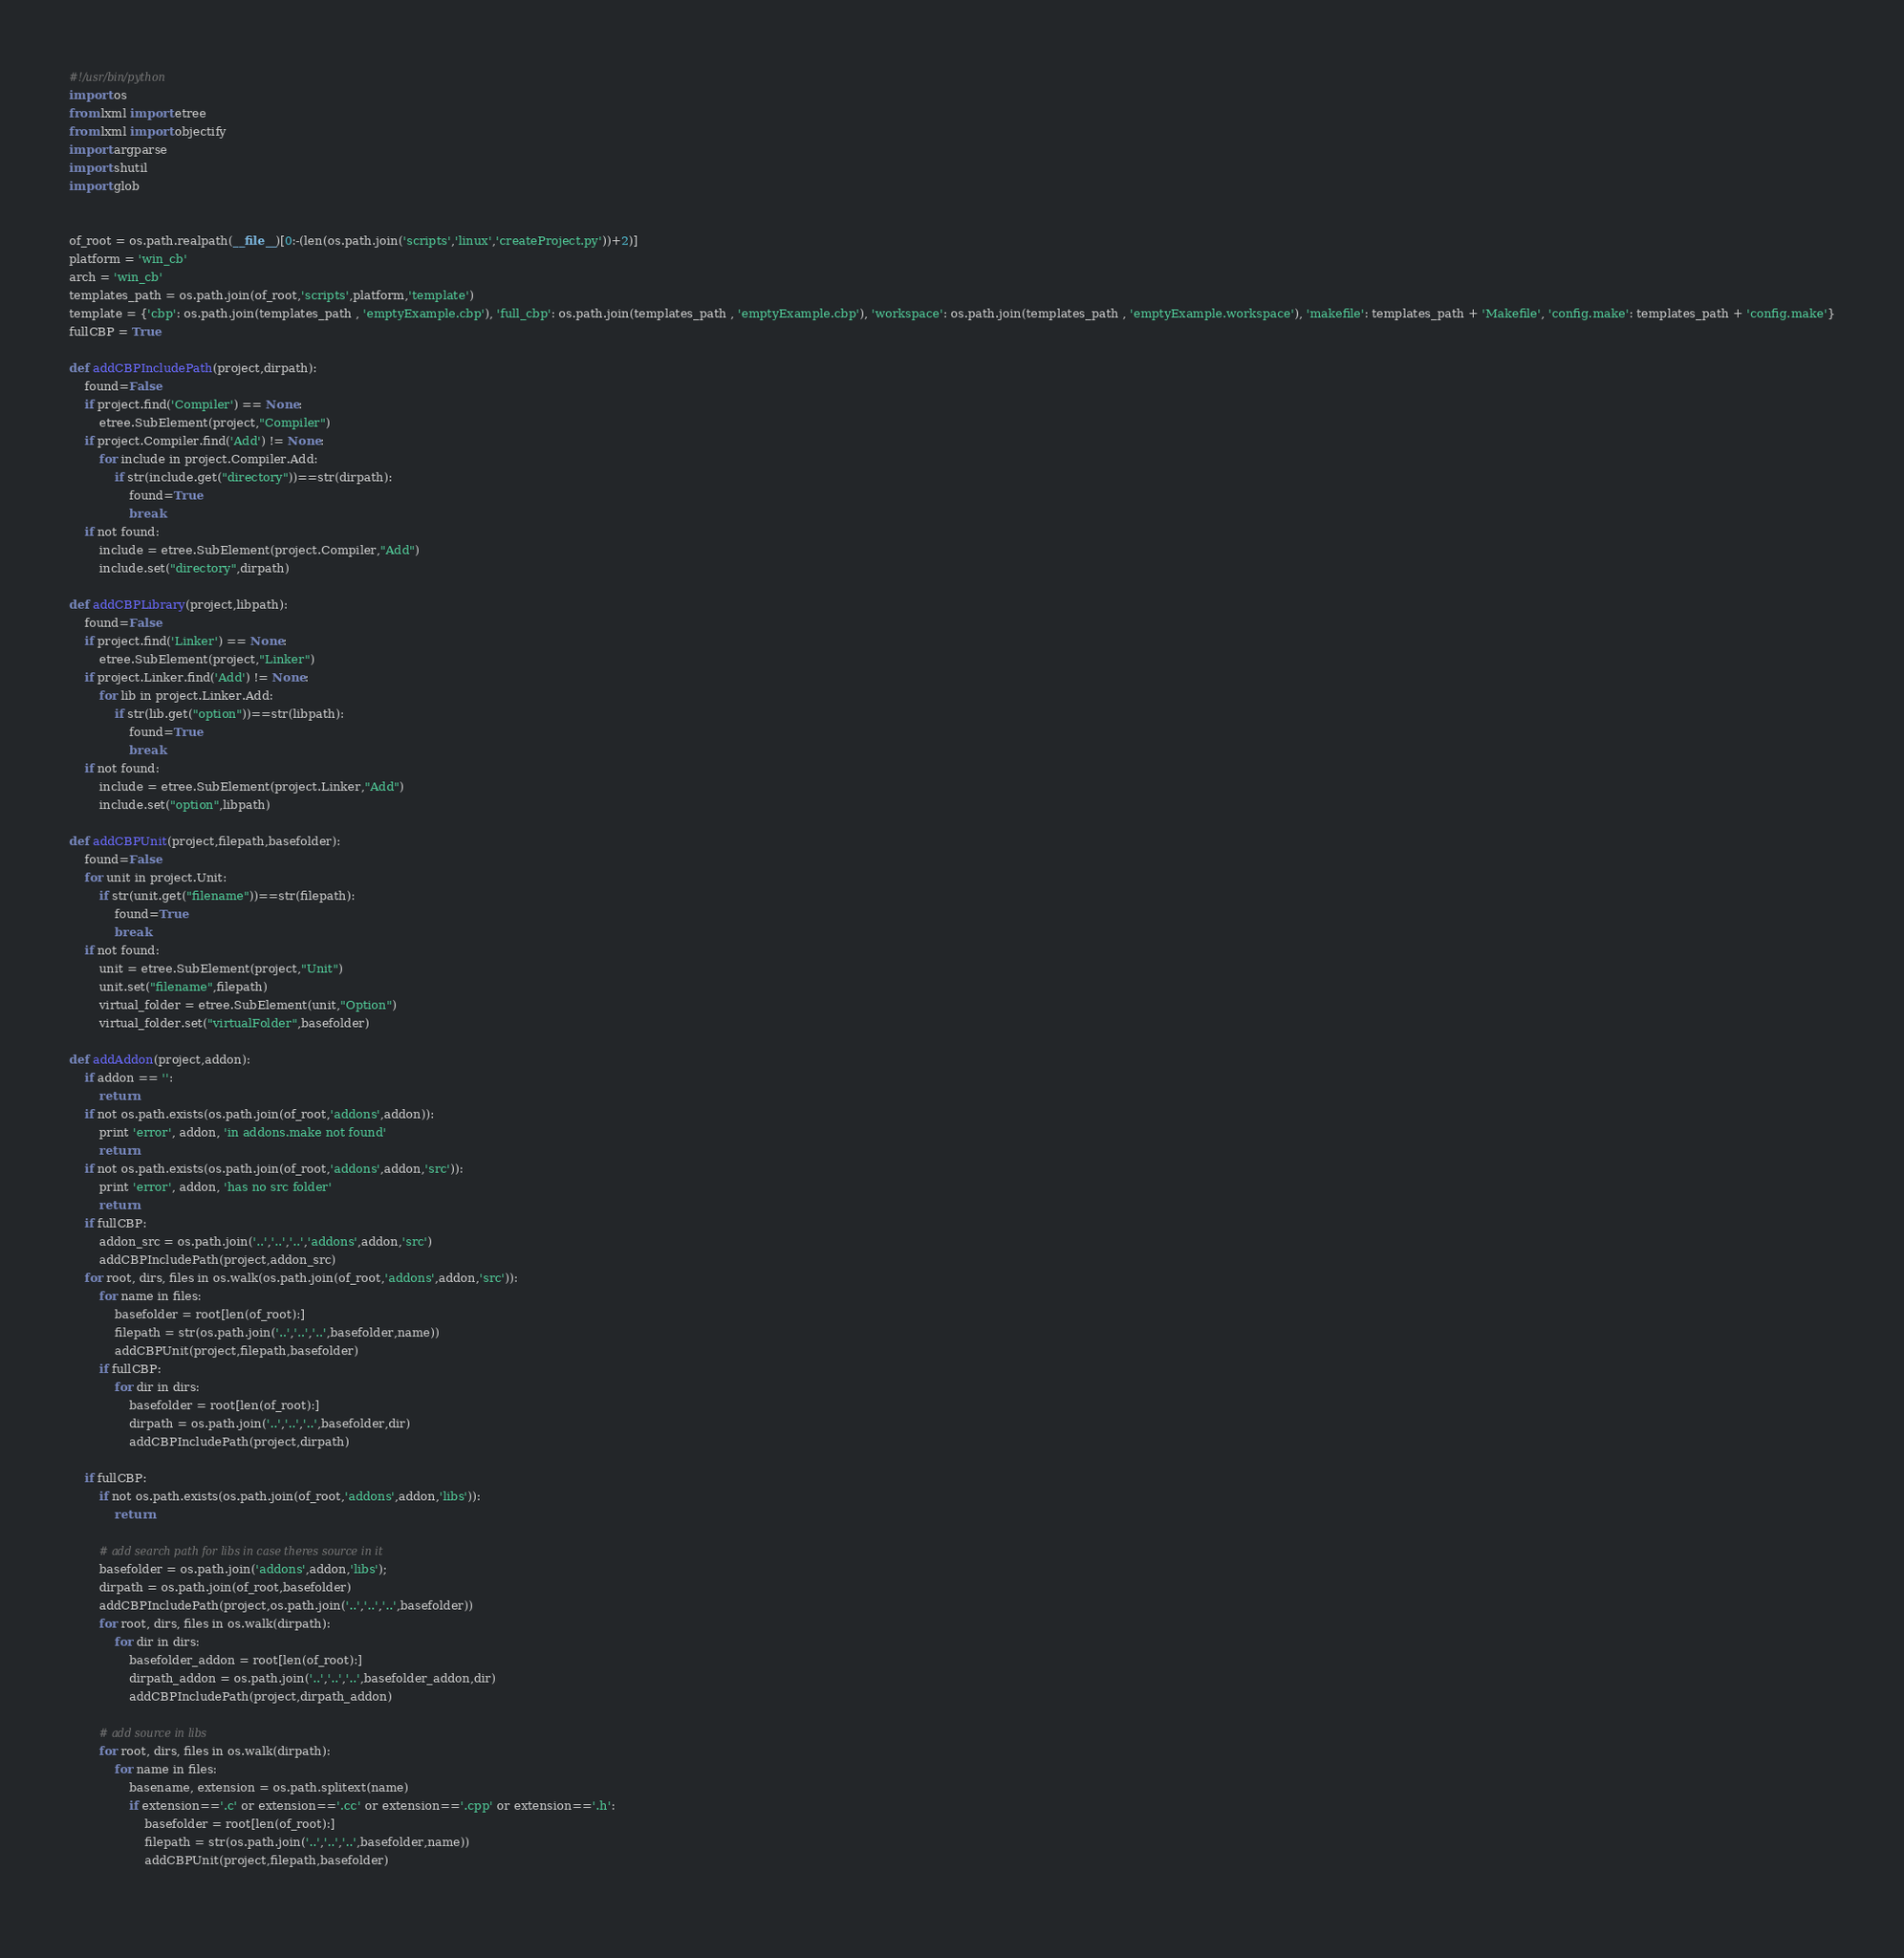Convert code to text. <code><loc_0><loc_0><loc_500><loc_500><_Python_>#!/usr/bin/python
import os
from lxml import etree
from lxml import objectify
import argparse
import shutil
import glob


of_root = os.path.realpath(__file__)[0:-(len(os.path.join('scripts','linux','createProject.py'))+2)]
platform = 'win_cb'
arch = 'win_cb'
templates_path = os.path.join(of_root,'scripts',platform,'template')
template = {'cbp': os.path.join(templates_path , 'emptyExample.cbp'), 'full_cbp': os.path.join(templates_path , 'emptyExample.cbp'), 'workspace': os.path.join(templates_path , 'emptyExample.workspace'), 'makefile': templates_path + 'Makefile', 'config.make': templates_path + 'config.make'}
fullCBP = True

def addCBPIncludePath(project,dirpath):
    found=False
    if project.find('Compiler') == None:
        etree.SubElement(project,"Compiler")
    if project.Compiler.find('Add') != None:
        for include in project.Compiler.Add:
            if str(include.get("directory"))==str(dirpath):
                found=True
                break
    if not found:
        include = etree.SubElement(project.Compiler,"Add")
        include.set("directory",dirpath)
        
def addCBPLibrary(project,libpath):
    found=False
    if project.find('Linker') == None:
        etree.SubElement(project,"Linker")
    if project.Linker.find('Add') != None:
        for lib in project.Linker.Add:
            if str(lib.get("option"))==str(libpath):
                found=True
                break
    if not found:
        include = etree.SubElement(project.Linker,"Add")
        include.set("option",libpath)
        
def addCBPUnit(project,filepath,basefolder):
    found=False
    for unit in project.Unit:
        if str(unit.get("filename"))==str(filepath):
            found=True
            break
    if not found:
        unit = etree.SubElement(project,"Unit")
        unit.set("filename",filepath)
        virtual_folder = etree.SubElement(unit,"Option")
        virtual_folder.set("virtualFolder",basefolder)

def addAddon(project,addon):
    if addon == '':
        return
    if not os.path.exists(os.path.join(of_root,'addons',addon)):
        print 'error', addon, 'in addons.make not found'
        return
    if not os.path.exists(os.path.join(of_root,'addons',addon,'src')):
        print 'error', addon, 'has no src folder'
        return
    if fullCBP:
        addon_src = os.path.join('..','..','..','addons',addon,'src')
        addCBPIncludePath(project,addon_src)
    for root, dirs, files in os.walk(os.path.join(of_root,'addons',addon,'src')):
        for name in files:
            basefolder = root[len(of_root):]
            filepath = str(os.path.join('..','..','..',basefolder,name))
            addCBPUnit(project,filepath,basefolder)
        if fullCBP:
            for dir in dirs:
                basefolder = root[len(of_root):]
                dirpath = os.path.join('..','..','..',basefolder,dir)
                addCBPIncludePath(project,dirpath)
    
    if fullCBP:
        if not os.path.exists(os.path.join(of_root,'addons',addon,'libs')):
            return
        
        # add search path for libs in case theres source in it
        basefolder = os.path.join('addons',addon,'libs');
        dirpath = os.path.join(of_root,basefolder)
        addCBPIncludePath(project,os.path.join('..','..','..',basefolder))
        for root, dirs, files in os.walk(dirpath):
            for dir in dirs:
                basefolder_addon = root[len(of_root):]
                dirpath_addon = os.path.join('..','..','..',basefolder_addon,dir)
                addCBPIncludePath(project,dirpath_addon)
        
        # add source in libs
        for root, dirs, files in os.walk(dirpath):
            for name in files:
                basename, extension = os.path.splitext(name)
                if extension=='.c' or extension=='.cc' or extension=='.cpp' or extension=='.h':
                    basefolder = root[len(of_root):]
                    filepath = str(os.path.join('..','..','..',basefolder,name))
                    addCBPUnit(project,filepath,basefolder)
                </code> 